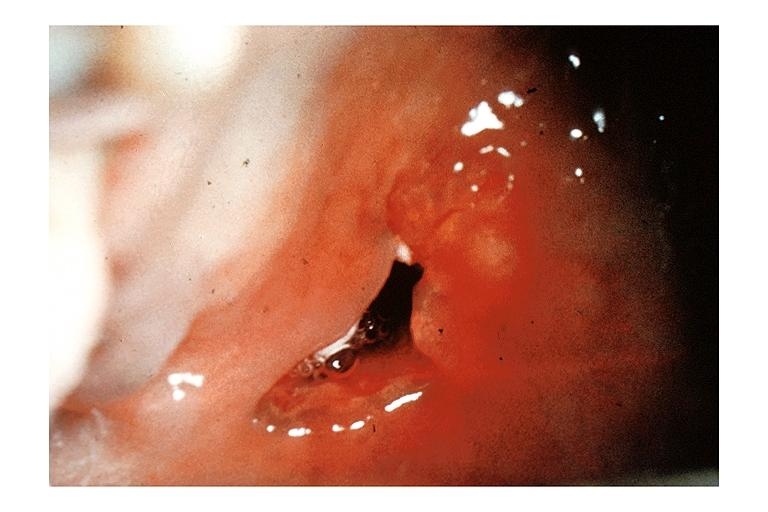s breast present?
Answer the question using a single word or phrase. No 